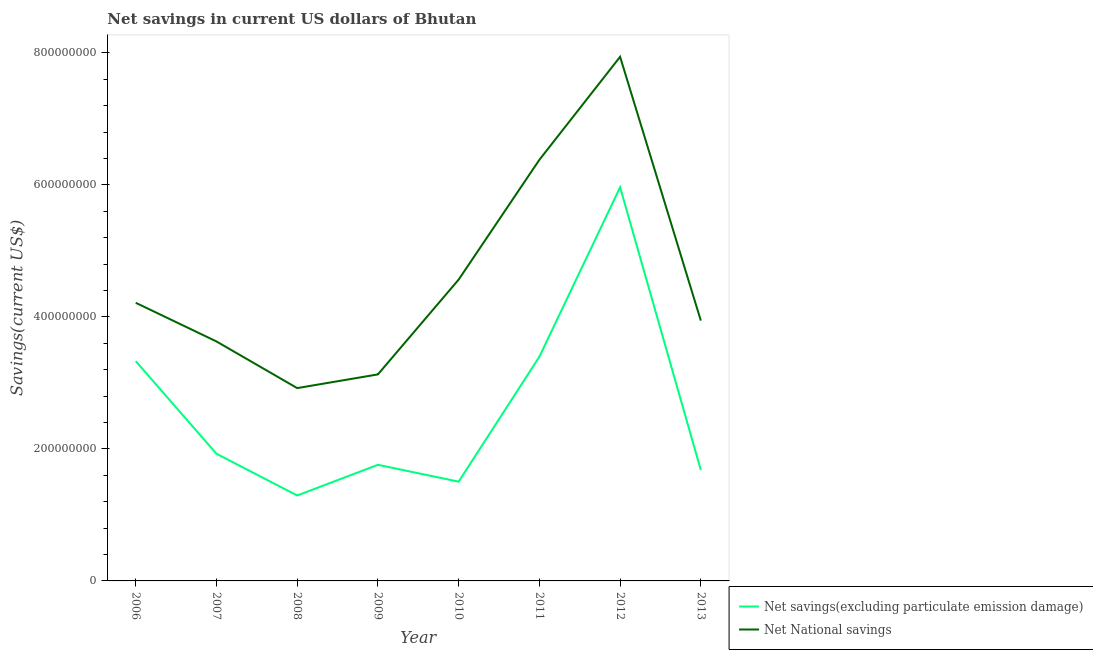What is the net national savings in 2007?
Make the answer very short. 3.63e+08. Across all years, what is the maximum net savings(excluding particulate emission damage)?
Keep it short and to the point. 5.96e+08. Across all years, what is the minimum net national savings?
Offer a very short reply. 2.92e+08. In which year was the net national savings maximum?
Provide a succinct answer. 2012. What is the total net savings(excluding particulate emission damage) in the graph?
Your answer should be very brief. 2.09e+09. What is the difference between the net savings(excluding particulate emission damage) in 2010 and that in 2013?
Provide a succinct answer. -1.76e+07. What is the difference between the net national savings in 2011 and the net savings(excluding particulate emission damage) in 2008?
Give a very brief answer. 5.09e+08. What is the average net savings(excluding particulate emission damage) per year?
Give a very brief answer. 2.61e+08. In the year 2009, what is the difference between the net savings(excluding particulate emission damage) and net national savings?
Your answer should be compact. -1.37e+08. In how many years, is the net national savings greater than 160000000 US$?
Make the answer very short. 8. What is the ratio of the net savings(excluding particulate emission damage) in 2007 to that in 2009?
Your answer should be compact. 1.1. What is the difference between the highest and the second highest net savings(excluding particulate emission damage)?
Keep it short and to the point. 2.57e+08. What is the difference between the highest and the lowest net savings(excluding particulate emission damage)?
Your response must be concise. 4.67e+08. Is the sum of the net national savings in 2011 and 2013 greater than the maximum net savings(excluding particulate emission damage) across all years?
Keep it short and to the point. Yes. Is the net savings(excluding particulate emission damage) strictly greater than the net national savings over the years?
Your answer should be compact. No. Is the net national savings strictly less than the net savings(excluding particulate emission damage) over the years?
Give a very brief answer. No. What is the difference between two consecutive major ticks on the Y-axis?
Provide a succinct answer. 2.00e+08. Are the values on the major ticks of Y-axis written in scientific E-notation?
Offer a very short reply. No. Where does the legend appear in the graph?
Offer a terse response. Bottom right. What is the title of the graph?
Ensure brevity in your answer.  Net savings in current US dollars of Bhutan. What is the label or title of the Y-axis?
Your response must be concise. Savings(current US$). What is the Savings(current US$) of Net savings(excluding particulate emission damage) in 2006?
Keep it short and to the point. 3.33e+08. What is the Savings(current US$) in Net National savings in 2006?
Your response must be concise. 4.21e+08. What is the Savings(current US$) of Net savings(excluding particulate emission damage) in 2007?
Provide a short and direct response. 1.93e+08. What is the Savings(current US$) of Net National savings in 2007?
Provide a short and direct response. 3.63e+08. What is the Savings(current US$) of Net savings(excluding particulate emission damage) in 2008?
Your response must be concise. 1.29e+08. What is the Savings(current US$) in Net National savings in 2008?
Your answer should be compact. 2.92e+08. What is the Savings(current US$) in Net savings(excluding particulate emission damage) in 2009?
Make the answer very short. 1.76e+08. What is the Savings(current US$) of Net National savings in 2009?
Offer a terse response. 3.13e+08. What is the Savings(current US$) in Net savings(excluding particulate emission damage) in 2010?
Provide a succinct answer. 1.50e+08. What is the Savings(current US$) in Net National savings in 2010?
Your response must be concise. 4.57e+08. What is the Savings(current US$) in Net savings(excluding particulate emission damage) in 2011?
Your response must be concise. 3.40e+08. What is the Savings(current US$) of Net National savings in 2011?
Offer a very short reply. 6.38e+08. What is the Savings(current US$) in Net savings(excluding particulate emission damage) in 2012?
Offer a very short reply. 5.96e+08. What is the Savings(current US$) in Net National savings in 2012?
Make the answer very short. 7.94e+08. What is the Savings(current US$) of Net savings(excluding particulate emission damage) in 2013?
Your answer should be compact. 1.68e+08. What is the Savings(current US$) in Net National savings in 2013?
Your response must be concise. 3.94e+08. Across all years, what is the maximum Savings(current US$) of Net savings(excluding particulate emission damage)?
Give a very brief answer. 5.96e+08. Across all years, what is the maximum Savings(current US$) of Net National savings?
Provide a succinct answer. 7.94e+08. Across all years, what is the minimum Savings(current US$) of Net savings(excluding particulate emission damage)?
Offer a terse response. 1.29e+08. Across all years, what is the minimum Savings(current US$) of Net National savings?
Offer a very short reply. 2.92e+08. What is the total Savings(current US$) of Net savings(excluding particulate emission damage) in the graph?
Offer a very short reply. 2.09e+09. What is the total Savings(current US$) of Net National savings in the graph?
Provide a short and direct response. 3.67e+09. What is the difference between the Savings(current US$) in Net savings(excluding particulate emission damage) in 2006 and that in 2007?
Offer a terse response. 1.40e+08. What is the difference between the Savings(current US$) of Net National savings in 2006 and that in 2007?
Your answer should be compact. 5.86e+07. What is the difference between the Savings(current US$) of Net savings(excluding particulate emission damage) in 2006 and that in 2008?
Keep it short and to the point. 2.04e+08. What is the difference between the Savings(current US$) of Net National savings in 2006 and that in 2008?
Ensure brevity in your answer.  1.29e+08. What is the difference between the Savings(current US$) in Net savings(excluding particulate emission damage) in 2006 and that in 2009?
Keep it short and to the point. 1.57e+08. What is the difference between the Savings(current US$) in Net National savings in 2006 and that in 2009?
Ensure brevity in your answer.  1.08e+08. What is the difference between the Savings(current US$) in Net savings(excluding particulate emission damage) in 2006 and that in 2010?
Ensure brevity in your answer.  1.83e+08. What is the difference between the Savings(current US$) in Net National savings in 2006 and that in 2010?
Offer a very short reply. -3.51e+07. What is the difference between the Savings(current US$) in Net savings(excluding particulate emission damage) in 2006 and that in 2011?
Ensure brevity in your answer.  -6.70e+06. What is the difference between the Savings(current US$) of Net National savings in 2006 and that in 2011?
Make the answer very short. -2.17e+08. What is the difference between the Savings(current US$) of Net savings(excluding particulate emission damage) in 2006 and that in 2012?
Give a very brief answer. -2.63e+08. What is the difference between the Savings(current US$) of Net National savings in 2006 and that in 2012?
Give a very brief answer. -3.73e+08. What is the difference between the Savings(current US$) in Net savings(excluding particulate emission damage) in 2006 and that in 2013?
Provide a short and direct response. 1.65e+08. What is the difference between the Savings(current US$) of Net National savings in 2006 and that in 2013?
Provide a short and direct response. 2.70e+07. What is the difference between the Savings(current US$) of Net savings(excluding particulate emission damage) in 2007 and that in 2008?
Keep it short and to the point. 6.32e+07. What is the difference between the Savings(current US$) in Net National savings in 2007 and that in 2008?
Ensure brevity in your answer.  7.07e+07. What is the difference between the Savings(current US$) of Net savings(excluding particulate emission damage) in 2007 and that in 2009?
Your answer should be compact. 1.67e+07. What is the difference between the Savings(current US$) of Net National savings in 2007 and that in 2009?
Your response must be concise. 4.99e+07. What is the difference between the Savings(current US$) of Net savings(excluding particulate emission damage) in 2007 and that in 2010?
Make the answer very short. 4.23e+07. What is the difference between the Savings(current US$) of Net National savings in 2007 and that in 2010?
Give a very brief answer. -9.37e+07. What is the difference between the Savings(current US$) in Net savings(excluding particulate emission damage) in 2007 and that in 2011?
Your answer should be compact. -1.47e+08. What is the difference between the Savings(current US$) in Net National savings in 2007 and that in 2011?
Keep it short and to the point. -2.75e+08. What is the difference between the Savings(current US$) in Net savings(excluding particulate emission damage) in 2007 and that in 2012?
Provide a short and direct response. -4.04e+08. What is the difference between the Savings(current US$) of Net National savings in 2007 and that in 2012?
Your answer should be very brief. -4.31e+08. What is the difference between the Savings(current US$) of Net savings(excluding particulate emission damage) in 2007 and that in 2013?
Keep it short and to the point. 2.46e+07. What is the difference between the Savings(current US$) of Net National savings in 2007 and that in 2013?
Your answer should be very brief. -3.16e+07. What is the difference between the Savings(current US$) of Net savings(excluding particulate emission damage) in 2008 and that in 2009?
Offer a terse response. -4.65e+07. What is the difference between the Savings(current US$) of Net National savings in 2008 and that in 2009?
Your answer should be compact. -2.08e+07. What is the difference between the Savings(current US$) of Net savings(excluding particulate emission damage) in 2008 and that in 2010?
Keep it short and to the point. -2.10e+07. What is the difference between the Savings(current US$) of Net National savings in 2008 and that in 2010?
Make the answer very short. -1.64e+08. What is the difference between the Savings(current US$) of Net savings(excluding particulate emission damage) in 2008 and that in 2011?
Keep it short and to the point. -2.10e+08. What is the difference between the Savings(current US$) in Net National savings in 2008 and that in 2011?
Your answer should be very brief. -3.46e+08. What is the difference between the Savings(current US$) of Net savings(excluding particulate emission damage) in 2008 and that in 2012?
Your answer should be very brief. -4.67e+08. What is the difference between the Savings(current US$) of Net National savings in 2008 and that in 2012?
Provide a short and direct response. -5.02e+08. What is the difference between the Savings(current US$) of Net savings(excluding particulate emission damage) in 2008 and that in 2013?
Your answer should be very brief. -3.86e+07. What is the difference between the Savings(current US$) in Net National savings in 2008 and that in 2013?
Keep it short and to the point. -1.02e+08. What is the difference between the Savings(current US$) of Net savings(excluding particulate emission damage) in 2009 and that in 2010?
Ensure brevity in your answer.  2.55e+07. What is the difference between the Savings(current US$) in Net National savings in 2009 and that in 2010?
Make the answer very short. -1.44e+08. What is the difference between the Savings(current US$) in Net savings(excluding particulate emission damage) in 2009 and that in 2011?
Offer a very short reply. -1.64e+08. What is the difference between the Savings(current US$) of Net National savings in 2009 and that in 2011?
Your answer should be very brief. -3.25e+08. What is the difference between the Savings(current US$) in Net savings(excluding particulate emission damage) in 2009 and that in 2012?
Your answer should be compact. -4.21e+08. What is the difference between the Savings(current US$) of Net National savings in 2009 and that in 2012?
Provide a succinct answer. -4.81e+08. What is the difference between the Savings(current US$) of Net savings(excluding particulate emission damage) in 2009 and that in 2013?
Provide a short and direct response. 7.91e+06. What is the difference between the Savings(current US$) in Net National savings in 2009 and that in 2013?
Give a very brief answer. -8.15e+07. What is the difference between the Savings(current US$) in Net savings(excluding particulate emission damage) in 2010 and that in 2011?
Give a very brief answer. -1.89e+08. What is the difference between the Savings(current US$) in Net National savings in 2010 and that in 2011?
Your answer should be very brief. -1.82e+08. What is the difference between the Savings(current US$) in Net savings(excluding particulate emission damage) in 2010 and that in 2012?
Your answer should be very brief. -4.46e+08. What is the difference between the Savings(current US$) of Net National savings in 2010 and that in 2012?
Offer a very short reply. -3.38e+08. What is the difference between the Savings(current US$) of Net savings(excluding particulate emission damage) in 2010 and that in 2013?
Offer a very short reply. -1.76e+07. What is the difference between the Savings(current US$) in Net National savings in 2010 and that in 2013?
Make the answer very short. 6.21e+07. What is the difference between the Savings(current US$) in Net savings(excluding particulate emission damage) in 2011 and that in 2012?
Your answer should be compact. -2.57e+08. What is the difference between the Savings(current US$) of Net National savings in 2011 and that in 2012?
Make the answer very short. -1.56e+08. What is the difference between the Savings(current US$) of Net savings(excluding particulate emission damage) in 2011 and that in 2013?
Offer a very short reply. 1.72e+08. What is the difference between the Savings(current US$) in Net National savings in 2011 and that in 2013?
Your answer should be very brief. 2.44e+08. What is the difference between the Savings(current US$) in Net savings(excluding particulate emission damage) in 2012 and that in 2013?
Give a very brief answer. 4.28e+08. What is the difference between the Savings(current US$) of Net National savings in 2012 and that in 2013?
Ensure brevity in your answer.  4.00e+08. What is the difference between the Savings(current US$) in Net savings(excluding particulate emission damage) in 2006 and the Savings(current US$) in Net National savings in 2007?
Your answer should be very brief. -2.99e+07. What is the difference between the Savings(current US$) in Net savings(excluding particulate emission damage) in 2006 and the Savings(current US$) in Net National savings in 2008?
Keep it short and to the point. 4.08e+07. What is the difference between the Savings(current US$) of Net savings(excluding particulate emission damage) in 2006 and the Savings(current US$) of Net National savings in 2009?
Offer a very short reply. 2.00e+07. What is the difference between the Savings(current US$) of Net savings(excluding particulate emission damage) in 2006 and the Savings(current US$) of Net National savings in 2010?
Ensure brevity in your answer.  -1.24e+08. What is the difference between the Savings(current US$) in Net savings(excluding particulate emission damage) in 2006 and the Savings(current US$) in Net National savings in 2011?
Make the answer very short. -3.05e+08. What is the difference between the Savings(current US$) in Net savings(excluding particulate emission damage) in 2006 and the Savings(current US$) in Net National savings in 2012?
Your answer should be compact. -4.61e+08. What is the difference between the Savings(current US$) in Net savings(excluding particulate emission damage) in 2006 and the Savings(current US$) in Net National savings in 2013?
Give a very brief answer. -6.15e+07. What is the difference between the Savings(current US$) of Net savings(excluding particulate emission damage) in 2007 and the Savings(current US$) of Net National savings in 2008?
Offer a terse response. -9.95e+07. What is the difference between the Savings(current US$) of Net savings(excluding particulate emission damage) in 2007 and the Savings(current US$) of Net National savings in 2009?
Give a very brief answer. -1.20e+08. What is the difference between the Savings(current US$) in Net savings(excluding particulate emission damage) in 2007 and the Savings(current US$) in Net National savings in 2010?
Give a very brief answer. -2.64e+08. What is the difference between the Savings(current US$) of Net savings(excluding particulate emission damage) in 2007 and the Savings(current US$) of Net National savings in 2011?
Provide a succinct answer. -4.45e+08. What is the difference between the Savings(current US$) in Net savings(excluding particulate emission damage) in 2007 and the Savings(current US$) in Net National savings in 2012?
Keep it short and to the point. -6.02e+08. What is the difference between the Savings(current US$) of Net savings(excluding particulate emission damage) in 2007 and the Savings(current US$) of Net National savings in 2013?
Offer a terse response. -2.02e+08. What is the difference between the Savings(current US$) in Net savings(excluding particulate emission damage) in 2008 and the Savings(current US$) in Net National savings in 2009?
Offer a terse response. -1.84e+08. What is the difference between the Savings(current US$) of Net savings(excluding particulate emission damage) in 2008 and the Savings(current US$) of Net National savings in 2010?
Offer a terse response. -3.27e+08. What is the difference between the Savings(current US$) in Net savings(excluding particulate emission damage) in 2008 and the Savings(current US$) in Net National savings in 2011?
Provide a short and direct response. -5.09e+08. What is the difference between the Savings(current US$) of Net savings(excluding particulate emission damage) in 2008 and the Savings(current US$) of Net National savings in 2012?
Keep it short and to the point. -6.65e+08. What is the difference between the Savings(current US$) in Net savings(excluding particulate emission damage) in 2008 and the Savings(current US$) in Net National savings in 2013?
Provide a short and direct response. -2.65e+08. What is the difference between the Savings(current US$) of Net savings(excluding particulate emission damage) in 2009 and the Savings(current US$) of Net National savings in 2010?
Your response must be concise. -2.81e+08. What is the difference between the Savings(current US$) of Net savings(excluding particulate emission damage) in 2009 and the Savings(current US$) of Net National savings in 2011?
Your answer should be very brief. -4.62e+08. What is the difference between the Savings(current US$) in Net savings(excluding particulate emission damage) in 2009 and the Savings(current US$) in Net National savings in 2012?
Give a very brief answer. -6.18e+08. What is the difference between the Savings(current US$) in Net savings(excluding particulate emission damage) in 2009 and the Savings(current US$) in Net National savings in 2013?
Your answer should be very brief. -2.19e+08. What is the difference between the Savings(current US$) in Net savings(excluding particulate emission damage) in 2010 and the Savings(current US$) in Net National savings in 2011?
Your answer should be very brief. -4.88e+08. What is the difference between the Savings(current US$) of Net savings(excluding particulate emission damage) in 2010 and the Savings(current US$) of Net National savings in 2012?
Provide a succinct answer. -6.44e+08. What is the difference between the Savings(current US$) of Net savings(excluding particulate emission damage) in 2010 and the Savings(current US$) of Net National savings in 2013?
Your answer should be compact. -2.44e+08. What is the difference between the Savings(current US$) in Net savings(excluding particulate emission damage) in 2011 and the Savings(current US$) in Net National savings in 2012?
Offer a very short reply. -4.54e+08. What is the difference between the Savings(current US$) in Net savings(excluding particulate emission damage) in 2011 and the Savings(current US$) in Net National savings in 2013?
Give a very brief answer. -5.48e+07. What is the difference between the Savings(current US$) of Net savings(excluding particulate emission damage) in 2012 and the Savings(current US$) of Net National savings in 2013?
Make the answer very short. 2.02e+08. What is the average Savings(current US$) of Net savings(excluding particulate emission damage) per year?
Provide a succinct answer. 2.61e+08. What is the average Savings(current US$) of Net National savings per year?
Your answer should be compact. 4.59e+08. In the year 2006, what is the difference between the Savings(current US$) of Net savings(excluding particulate emission damage) and Savings(current US$) of Net National savings?
Offer a very short reply. -8.84e+07. In the year 2007, what is the difference between the Savings(current US$) in Net savings(excluding particulate emission damage) and Savings(current US$) in Net National savings?
Your answer should be very brief. -1.70e+08. In the year 2008, what is the difference between the Savings(current US$) in Net savings(excluding particulate emission damage) and Savings(current US$) in Net National savings?
Your answer should be very brief. -1.63e+08. In the year 2009, what is the difference between the Savings(current US$) of Net savings(excluding particulate emission damage) and Savings(current US$) of Net National savings?
Give a very brief answer. -1.37e+08. In the year 2010, what is the difference between the Savings(current US$) of Net savings(excluding particulate emission damage) and Savings(current US$) of Net National savings?
Make the answer very short. -3.06e+08. In the year 2011, what is the difference between the Savings(current US$) of Net savings(excluding particulate emission damage) and Savings(current US$) of Net National savings?
Ensure brevity in your answer.  -2.98e+08. In the year 2012, what is the difference between the Savings(current US$) in Net savings(excluding particulate emission damage) and Savings(current US$) in Net National savings?
Your answer should be compact. -1.98e+08. In the year 2013, what is the difference between the Savings(current US$) in Net savings(excluding particulate emission damage) and Savings(current US$) in Net National savings?
Provide a succinct answer. -2.26e+08. What is the ratio of the Savings(current US$) in Net savings(excluding particulate emission damage) in 2006 to that in 2007?
Offer a very short reply. 1.73. What is the ratio of the Savings(current US$) of Net National savings in 2006 to that in 2007?
Your answer should be compact. 1.16. What is the ratio of the Savings(current US$) of Net savings(excluding particulate emission damage) in 2006 to that in 2008?
Offer a very short reply. 2.57. What is the ratio of the Savings(current US$) of Net National savings in 2006 to that in 2008?
Offer a terse response. 1.44. What is the ratio of the Savings(current US$) of Net savings(excluding particulate emission damage) in 2006 to that in 2009?
Provide a succinct answer. 1.89. What is the ratio of the Savings(current US$) of Net National savings in 2006 to that in 2009?
Ensure brevity in your answer.  1.35. What is the ratio of the Savings(current US$) of Net savings(excluding particulate emission damage) in 2006 to that in 2010?
Your response must be concise. 2.21. What is the ratio of the Savings(current US$) of Net National savings in 2006 to that in 2010?
Offer a very short reply. 0.92. What is the ratio of the Savings(current US$) of Net savings(excluding particulate emission damage) in 2006 to that in 2011?
Offer a terse response. 0.98. What is the ratio of the Savings(current US$) in Net National savings in 2006 to that in 2011?
Your response must be concise. 0.66. What is the ratio of the Savings(current US$) of Net savings(excluding particulate emission damage) in 2006 to that in 2012?
Your answer should be compact. 0.56. What is the ratio of the Savings(current US$) in Net National savings in 2006 to that in 2012?
Provide a short and direct response. 0.53. What is the ratio of the Savings(current US$) of Net savings(excluding particulate emission damage) in 2006 to that in 2013?
Offer a terse response. 1.98. What is the ratio of the Savings(current US$) of Net National savings in 2006 to that in 2013?
Your response must be concise. 1.07. What is the ratio of the Savings(current US$) of Net savings(excluding particulate emission damage) in 2007 to that in 2008?
Your answer should be compact. 1.49. What is the ratio of the Savings(current US$) in Net National savings in 2007 to that in 2008?
Offer a very short reply. 1.24. What is the ratio of the Savings(current US$) of Net savings(excluding particulate emission damage) in 2007 to that in 2009?
Give a very brief answer. 1.1. What is the ratio of the Savings(current US$) of Net National savings in 2007 to that in 2009?
Your answer should be compact. 1.16. What is the ratio of the Savings(current US$) of Net savings(excluding particulate emission damage) in 2007 to that in 2010?
Make the answer very short. 1.28. What is the ratio of the Savings(current US$) of Net National savings in 2007 to that in 2010?
Keep it short and to the point. 0.79. What is the ratio of the Savings(current US$) of Net savings(excluding particulate emission damage) in 2007 to that in 2011?
Keep it short and to the point. 0.57. What is the ratio of the Savings(current US$) in Net National savings in 2007 to that in 2011?
Offer a very short reply. 0.57. What is the ratio of the Savings(current US$) in Net savings(excluding particulate emission damage) in 2007 to that in 2012?
Your answer should be very brief. 0.32. What is the ratio of the Savings(current US$) in Net National savings in 2007 to that in 2012?
Offer a very short reply. 0.46. What is the ratio of the Savings(current US$) in Net savings(excluding particulate emission damage) in 2007 to that in 2013?
Ensure brevity in your answer.  1.15. What is the ratio of the Savings(current US$) of Net National savings in 2007 to that in 2013?
Ensure brevity in your answer.  0.92. What is the ratio of the Savings(current US$) in Net savings(excluding particulate emission damage) in 2008 to that in 2009?
Ensure brevity in your answer.  0.74. What is the ratio of the Savings(current US$) of Net National savings in 2008 to that in 2009?
Ensure brevity in your answer.  0.93. What is the ratio of the Savings(current US$) of Net savings(excluding particulate emission damage) in 2008 to that in 2010?
Offer a very short reply. 0.86. What is the ratio of the Savings(current US$) in Net National savings in 2008 to that in 2010?
Provide a short and direct response. 0.64. What is the ratio of the Savings(current US$) of Net savings(excluding particulate emission damage) in 2008 to that in 2011?
Offer a very short reply. 0.38. What is the ratio of the Savings(current US$) in Net National savings in 2008 to that in 2011?
Provide a short and direct response. 0.46. What is the ratio of the Savings(current US$) of Net savings(excluding particulate emission damage) in 2008 to that in 2012?
Give a very brief answer. 0.22. What is the ratio of the Savings(current US$) in Net National savings in 2008 to that in 2012?
Your response must be concise. 0.37. What is the ratio of the Savings(current US$) in Net savings(excluding particulate emission damage) in 2008 to that in 2013?
Offer a terse response. 0.77. What is the ratio of the Savings(current US$) in Net National savings in 2008 to that in 2013?
Your response must be concise. 0.74. What is the ratio of the Savings(current US$) in Net savings(excluding particulate emission damage) in 2009 to that in 2010?
Your answer should be very brief. 1.17. What is the ratio of the Savings(current US$) of Net National savings in 2009 to that in 2010?
Ensure brevity in your answer.  0.69. What is the ratio of the Savings(current US$) of Net savings(excluding particulate emission damage) in 2009 to that in 2011?
Give a very brief answer. 0.52. What is the ratio of the Savings(current US$) in Net National savings in 2009 to that in 2011?
Provide a short and direct response. 0.49. What is the ratio of the Savings(current US$) of Net savings(excluding particulate emission damage) in 2009 to that in 2012?
Your response must be concise. 0.29. What is the ratio of the Savings(current US$) of Net National savings in 2009 to that in 2012?
Your response must be concise. 0.39. What is the ratio of the Savings(current US$) of Net savings(excluding particulate emission damage) in 2009 to that in 2013?
Give a very brief answer. 1.05. What is the ratio of the Savings(current US$) in Net National savings in 2009 to that in 2013?
Make the answer very short. 0.79. What is the ratio of the Savings(current US$) in Net savings(excluding particulate emission damage) in 2010 to that in 2011?
Ensure brevity in your answer.  0.44. What is the ratio of the Savings(current US$) of Net National savings in 2010 to that in 2011?
Provide a succinct answer. 0.72. What is the ratio of the Savings(current US$) of Net savings(excluding particulate emission damage) in 2010 to that in 2012?
Provide a succinct answer. 0.25. What is the ratio of the Savings(current US$) in Net National savings in 2010 to that in 2012?
Ensure brevity in your answer.  0.57. What is the ratio of the Savings(current US$) in Net savings(excluding particulate emission damage) in 2010 to that in 2013?
Your answer should be very brief. 0.9. What is the ratio of the Savings(current US$) in Net National savings in 2010 to that in 2013?
Your answer should be very brief. 1.16. What is the ratio of the Savings(current US$) in Net savings(excluding particulate emission damage) in 2011 to that in 2012?
Give a very brief answer. 0.57. What is the ratio of the Savings(current US$) in Net National savings in 2011 to that in 2012?
Your response must be concise. 0.8. What is the ratio of the Savings(current US$) in Net savings(excluding particulate emission damage) in 2011 to that in 2013?
Offer a terse response. 2.02. What is the ratio of the Savings(current US$) of Net National savings in 2011 to that in 2013?
Offer a very short reply. 1.62. What is the ratio of the Savings(current US$) in Net savings(excluding particulate emission damage) in 2012 to that in 2013?
Offer a very short reply. 3.55. What is the ratio of the Savings(current US$) in Net National savings in 2012 to that in 2013?
Offer a terse response. 2.01. What is the difference between the highest and the second highest Savings(current US$) of Net savings(excluding particulate emission damage)?
Offer a very short reply. 2.57e+08. What is the difference between the highest and the second highest Savings(current US$) in Net National savings?
Offer a very short reply. 1.56e+08. What is the difference between the highest and the lowest Savings(current US$) of Net savings(excluding particulate emission damage)?
Offer a very short reply. 4.67e+08. What is the difference between the highest and the lowest Savings(current US$) in Net National savings?
Your answer should be very brief. 5.02e+08. 